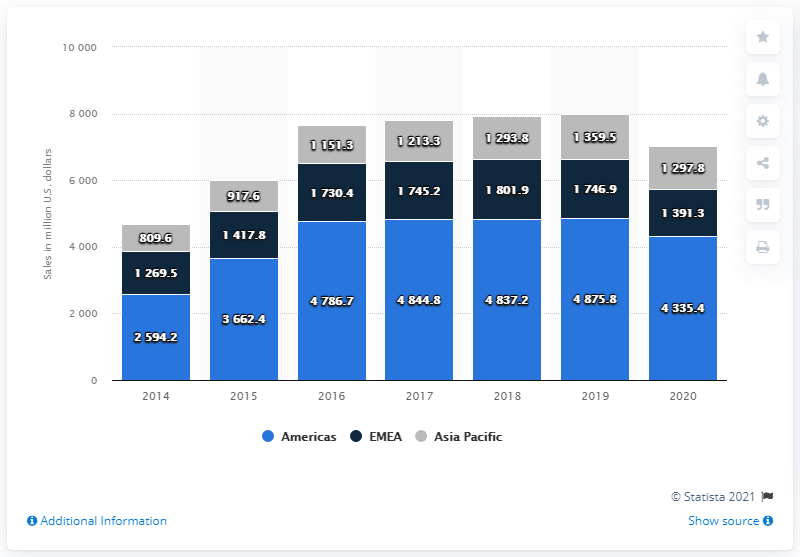Highlight a few significant elements in this photo. In 2020, Zimmer Biomet's net sales in the American region were $43,354.4. In 2020, the region with sales valued at 1.4 billion U.S. dollars was the EMEA region. 